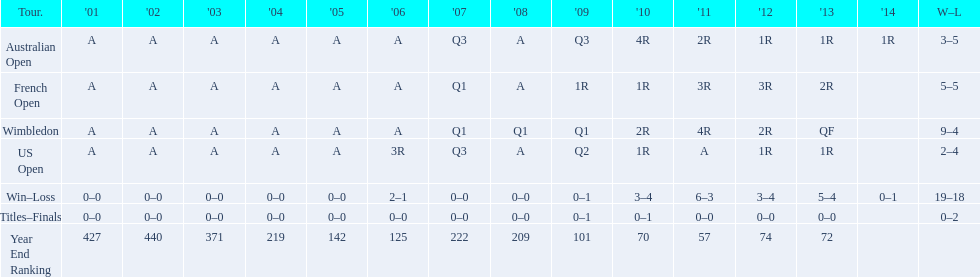What is the difference in wins between wimbledon and the us open for this player? 7. 